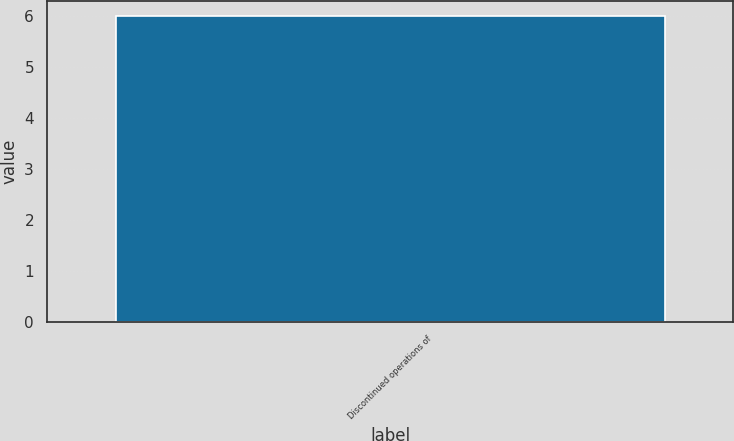Convert chart. <chart><loc_0><loc_0><loc_500><loc_500><bar_chart><fcel>Discontinued operations of<nl><fcel>6<nl></chart> 